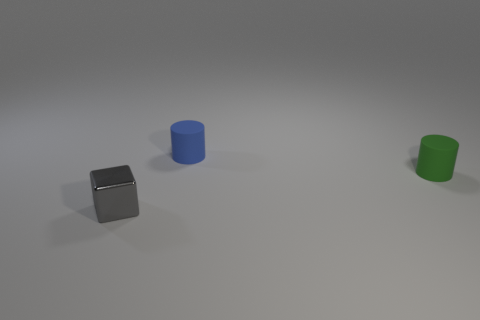Add 1 green metal spheres. How many objects exist? 4 Subtract all big blue matte spheres. Subtract all shiny objects. How many objects are left? 2 Add 1 rubber cylinders. How many rubber cylinders are left? 3 Add 3 small metallic blocks. How many small metallic blocks exist? 4 Subtract 0 yellow blocks. How many objects are left? 3 Subtract all cylinders. How many objects are left? 1 